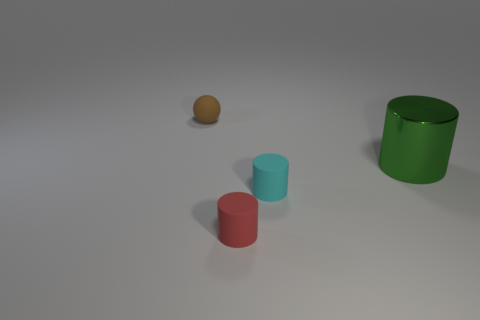Subtract all cyan rubber cylinders. How many cylinders are left? 2 Add 4 big green shiny things. How many objects exist? 8 Subtract all green cylinders. How many cylinders are left? 2 Subtract 0 gray cylinders. How many objects are left? 4 Subtract all cylinders. How many objects are left? 1 Subtract 2 cylinders. How many cylinders are left? 1 Subtract all purple balls. Subtract all green cylinders. How many balls are left? 1 Subtract all brown balls. How many green cylinders are left? 1 Subtract all big gray balls. Subtract all matte balls. How many objects are left? 3 Add 2 tiny cyan matte cylinders. How many tiny cyan matte cylinders are left? 3 